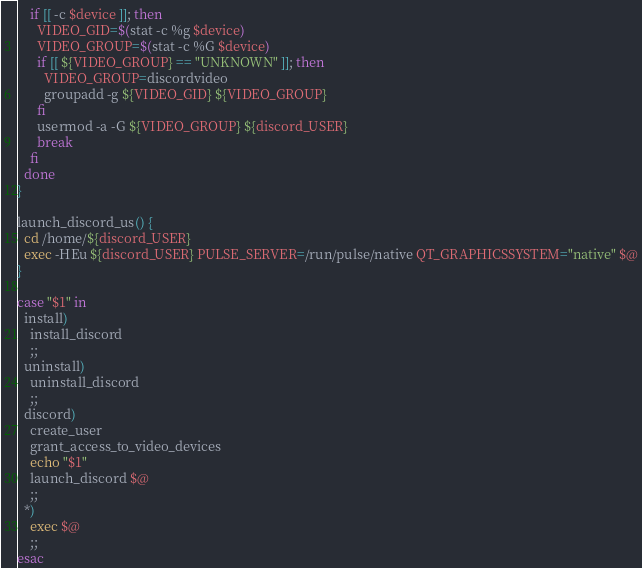<code> <loc_0><loc_0><loc_500><loc_500><_Bash_>    if [[ -c $device ]]; then
      VIDEO_GID=$(stat -c %g $device)
      VIDEO_GROUP=$(stat -c %G $device)
      if [[ ${VIDEO_GROUP} == "UNKNOWN" ]]; then
        VIDEO_GROUP=discordvideo
        groupadd -g ${VIDEO_GID} ${VIDEO_GROUP}
      fi
      usermod -a -G ${VIDEO_GROUP} ${discord_USER}
      break
    fi
  done
}

launch_discord_us() {
  cd /home/${discord_USER}
  exec -HEu ${discord_USER} PULSE_SERVER=/run/pulse/native QT_GRAPHICSSYSTEM="native" $@
}

case "$1" in
  install)
    install_discord
    ;;
  uninstall)
    uninstall_discord
    ;;
  discord)
    create_user
    grant_access_to_video_devices
    echo "$1"
    launch_discord $@
    ;;
  *)
    exec $@
    ;;
esac
</code> 